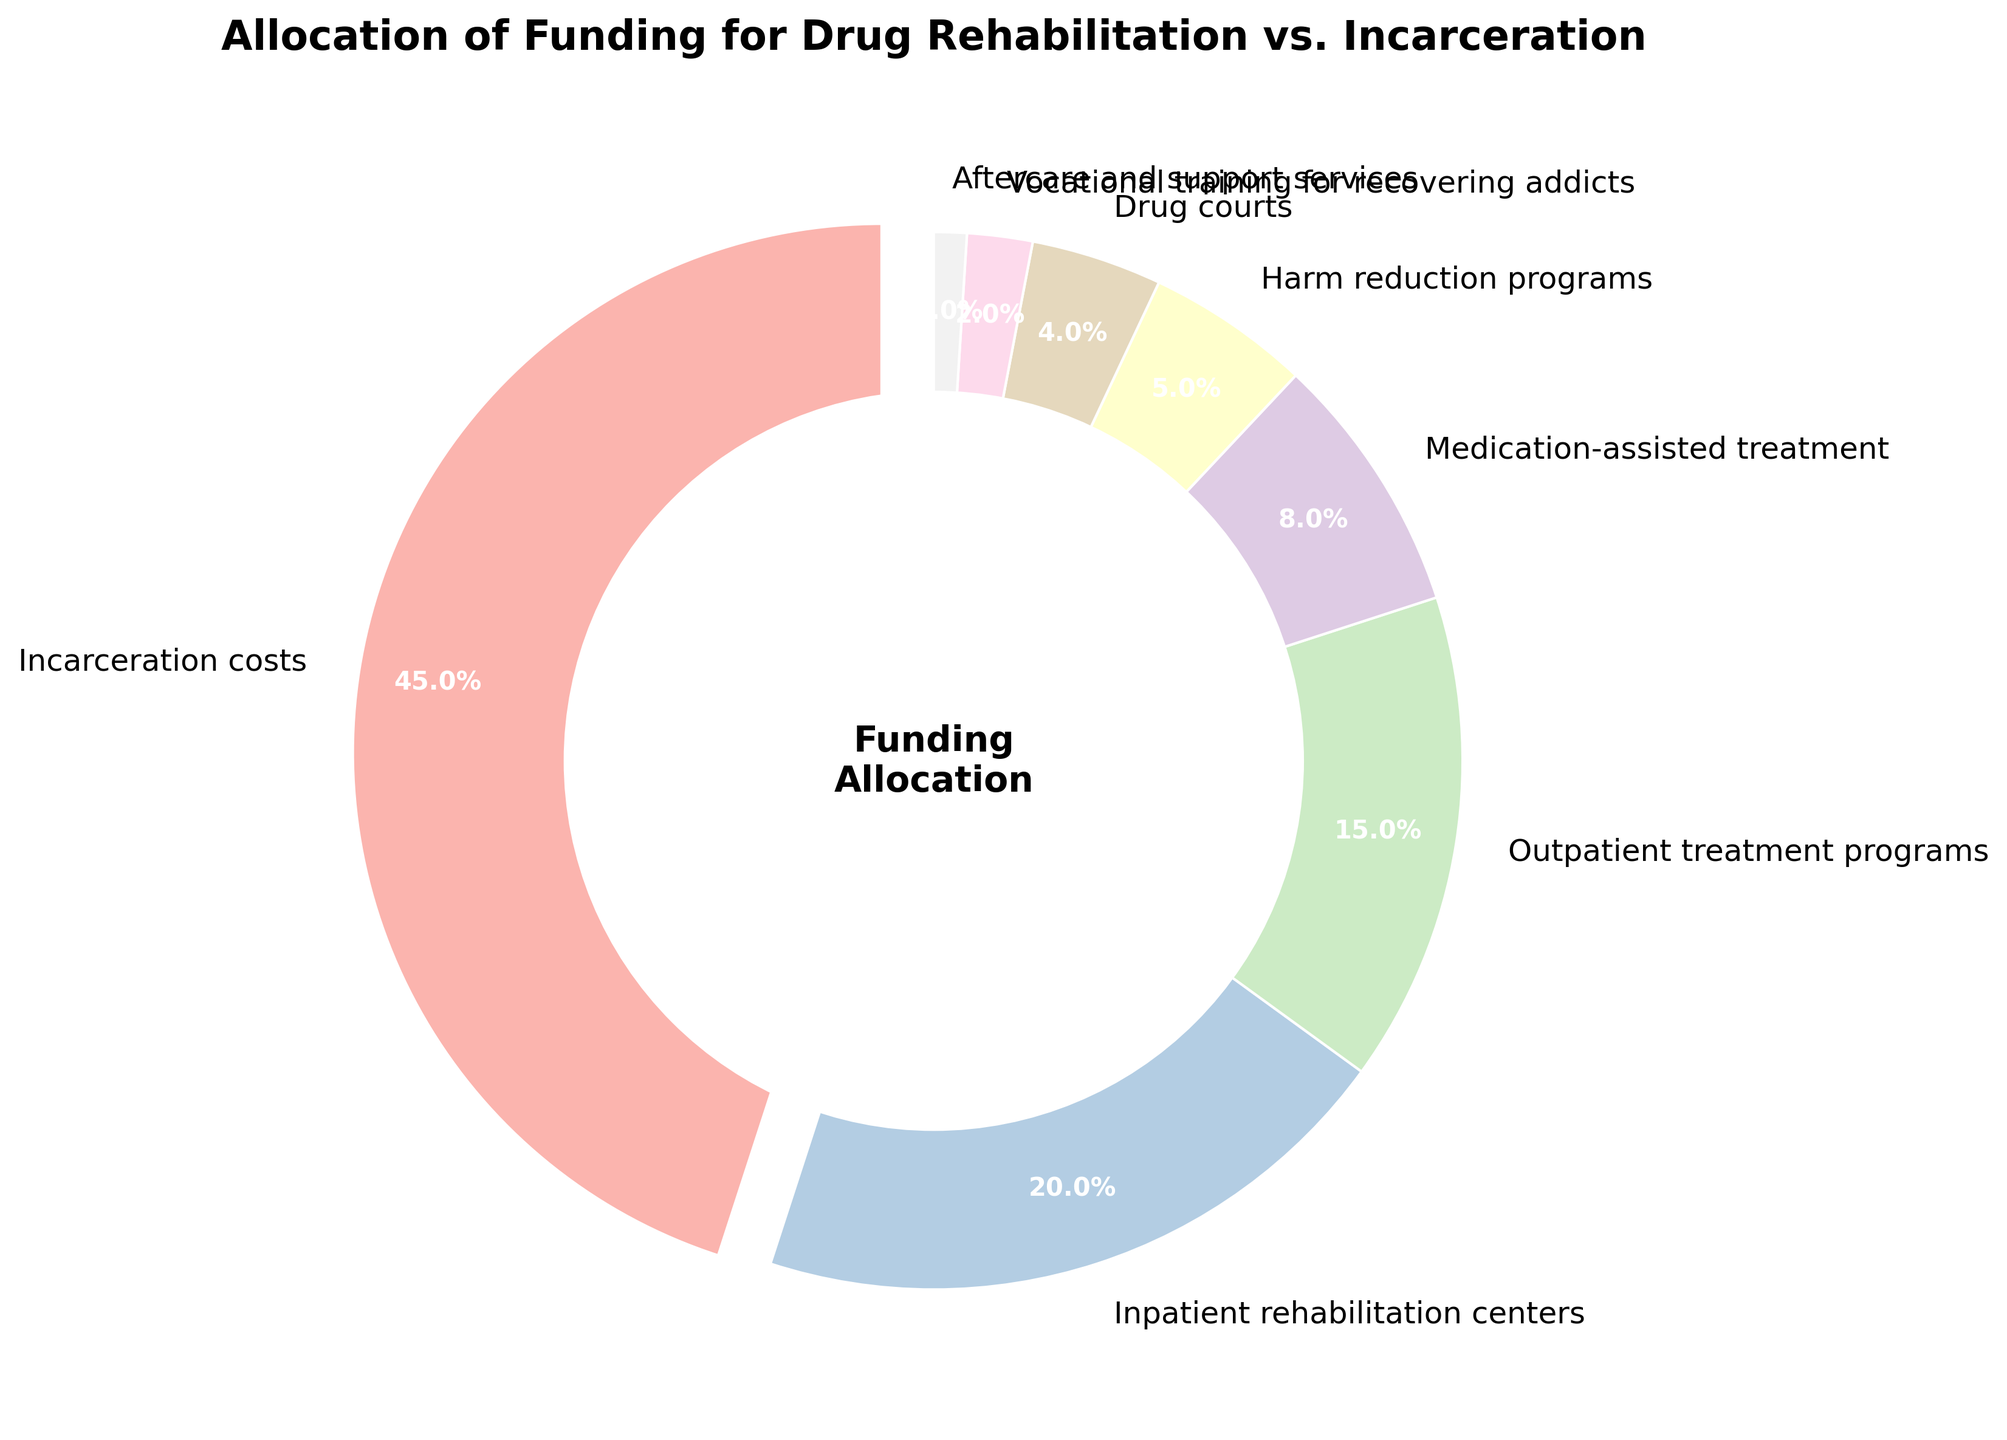What percentage of funding is allocated to drug courts? In the pie chart, locate the section labeled "Drug courts" and read the percentage next to it.
Answer: 4% Which category receives the highest allocation of funding? Identify the section of the pie chart with the largest size and read its label.
Answer: Incarceration costs How much more funding percentage is allocated to inpatient rehabilitation centers than to outpatient treatment programs? Find the percentages for both "Inpatient rehabilitation centers" and "Outpatient treatment programs" on the pie chart, then subtract the smaller percentage from the larger one.
Answer: 5% What is the combined percentage allocation for Medication-assisted treatment and Harm reduction programs? Add the percentages of "Medication-assisted treatment" and "Harm reduction programs" on the pie chart.
Answer: 13% Is the percentage allocation for aftercare and support services greater than that of vocational training for recovering addicts? Compare the percentages for "Aftercare and support services" and "Vocational training for recovering addicts" from the pie chart.
Answer: No Which category has the least funding allocation, and what is its percentage? Locate the smallest section in the pie chart and read its label and percentage.
Answer: Aftercare and support services, 1% Which two categories together make up exactly a quarter (25%) of the funding allocation? Find two sections in the pie chart whose percentages add up to 25% by visually grouping smaller sections and adding their percentages.
Answer: Drug courts (4%) and Outpatient treatment programs (15%) and Harm reduction programs (5%) If the funding for harm reduction programs were doubled, what would its new percentage allocation be? Multiply the percentage of "Harm reduction programs" by 2.
Answer: 10% What is the difference in percentage allocation between inpatient rehabilitation centers and vocational training for recovering addicts? Subtract the percentage of "Vocational training for recovering addicts" from the percentage of "Inpatient rehabilitation centers."
Answer: 18% What visual feature highlights the category with the highest percentage allocation in the pie chart? Describe the visual attribute used to emphasize the section with the largest percentage.
Answer: The wedge is separated from the rest (exploded) 